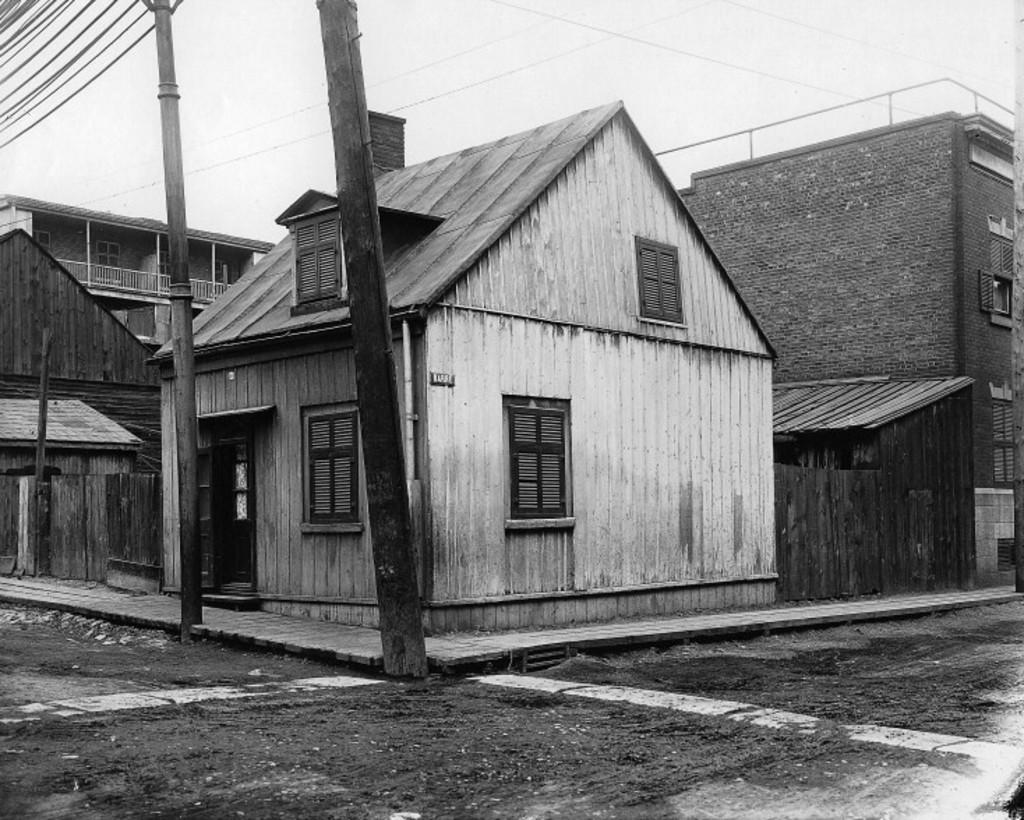What type of structures can be seen in the image? There are buildings in the image. What else can be seen in the image besides the buildings? There are poles, a road, and wires visible in the image. Where is the road located in the image? The road is at the bottom of the image. What is visible in the background of the image? The sky is visible in the background of the image. Can you tell me how many people are participating in the protest in the image? There is no protest present in the image; it features buildings, poles, a road, wires, and the sky. Where is the grandmother sitting in the image? There is no grandmother present in the image. 